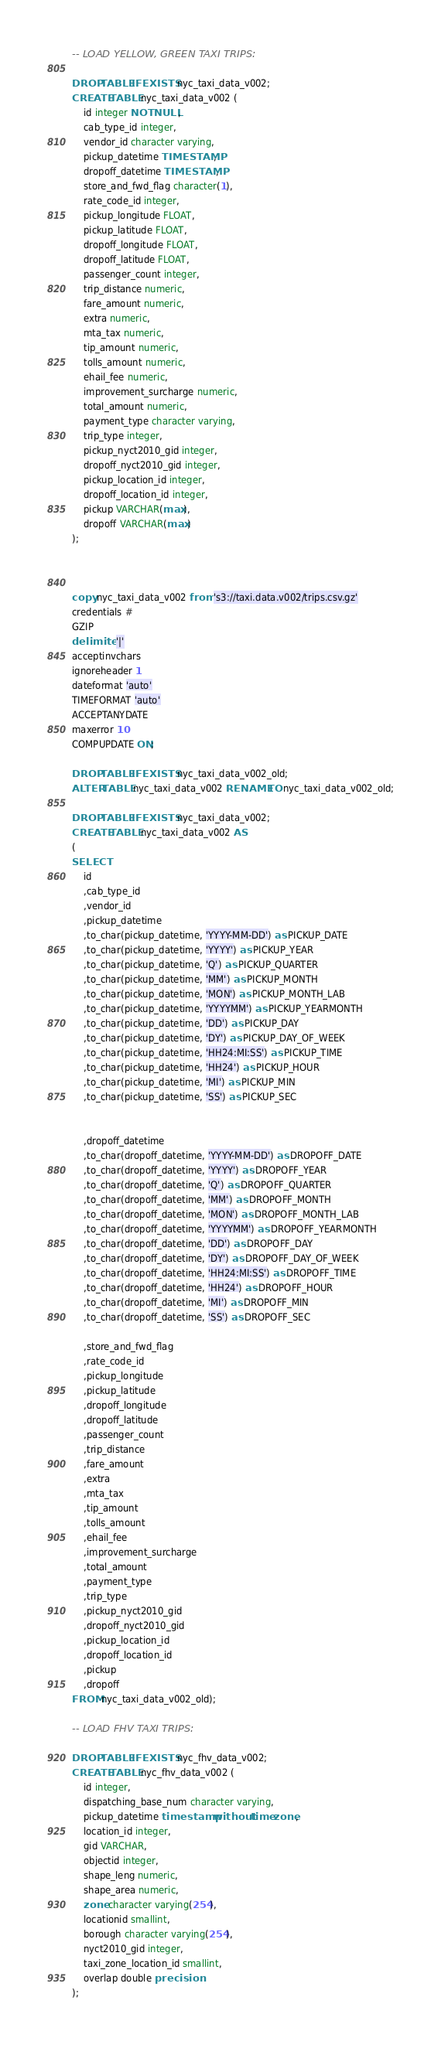<code> <loc_0><loc_0><loc_500><loc_500><_SQL_>-- LOAD YELLOW, GREEN TAXI TRIPS:

DROP TABLE IF EXISTS nyc_taxi_data_v002;
CREATE TABLE nyc_taxi_data_v002 (
    id integer NOT NULL,
    cab_type_id integer,
    vendor_id character varying,
    pickup_datetime TIMESTAMP,
    dropoff_datetime TIMESTAMP,
    store_and_fwd_flag character(1),
    rate_code_id integer,
    pickup_longitude FLOAT,
    pickup_latitude FLOAT,
    dropoff_longitude FLOAT,
    dropoff_latitude FLOAT,
    passenger_count integer,
    trip_distance numeric,
    fare_amount numeric,
    extra numeric,
    mta_tax numeric,
    tip_amount numeric,
    tolls_amount numeric,
    ehail_fee numeric,
    improvement_surcharge numeric,
    total_amount numeric,
    payment_type character varying,
    trip_type integer,
    pickup_nyct2010_gid integer,
    dropoff_nyct2010_gid integer,
    pickup_location_id integer,
    dropoff_location_id integer,
    pickup VARCHAR(max),
    dropoff VARCHAR(max)
);



copy nyc_taxi_data_v002 from 's3://taxi.data.v002/trips.csv.gz'
credentials #
GZIP
delimiter '|'
acceptinvchars
ignoreheader 1
dateformat 'auto'
TIMEFORMAT 'auto'
ACCEPTANYDATE
maxerror 10
COMPUPDATE ON;

DROP TABLE IF EXISTS nyc_taxi_data_v002_old;
ALTER TABLE nyc_taxi_data_v002 RENAME TO nyc_taxi_data_v002_old;

DROP TABLE IF EXISTS nyc_taxi_data_v002;
CREATE TABLE nyc_taxi_data_v002 AS 
(
SELECT 
    id 
    ,cab_type_id
    ,vendor_id
    ,pickup_datetime
    ,to_char(pickup_datetime, 'YYYY-MM-DD') as PICKUP_DATE
    ,to_char(pickup_datetime, 'YYYY') as PICKUP_YEAR
    ,to_char(pickup_datetime, 'Q') as PICKUP_QUARTER
    ,to_char(pickup_datetime, 'MM') as PICKUP_MONTH
    ,to_char(pickup_datetime, 'MON') as PICKUP_MONTH_LAB
    ,to_char(pickup_datetime, 'YYYYMM') as PICKUP_YEARMONTH
    ,to_char(pickup_datetime, 'DD') as PICKUP_DAY
    ,to_char(pickup_datetime, 'DY') as PICKUP_DAY_OF_WEEK
    ,to_char(pickup_datetime, 'HH24:MI:SS') as PICKUP_TIME
    ,to_char(pickup_datetime, 'HH24') as PICKUP_HOUR
    ,to_char(pickup_datetime, 'MI') as PICKUP_MIN
    ,to_char(pickup_datetime, 'SS') as PICKUP_SEC

    
    ,dropoff_datetime
    ,to_char(dropoff_datetime, 'YYYY-MM-DD') as DROPOFF_DATE
    ,to_char(dropoff_datetime, 'YYYY') as DROPOFF_YEAR
    ,to_char(dropoff_datetime, 'Q') as DROPOFF_QUARTER
    ,to_char(dropoff_datetime, 'MM') as DROPOFF_MONTH
    ,to_char(dropoff_datetime, 'MON') as DROPOFF_MONTH_LAB
    ,to_char(dropoff_datetime, 'YYYYMM') as DROPOFF_YEARMONTH
    ,to_char(dropoff_datetime, 'DD') as DROPOFF_DAY
    ,to_char(dropoff_datetime, 'DY') as DROPOFF_DAY_OF_WEEK
    ,to_char(dropoff_datetime, 'HH24:MI:SS') as DROPOFF_TIME
    ,to_char(dropoff_datetime, 'HH24') as DROPOFF_HOUR
    ,to_char(dropoff_datetime, 'MI') as DROPOFF_MIN
    ,to_char(dropoff_datetime, 'SS') as DROPOFF_SEC
    
    ,store_and_fwd_flag
    ,rate_code_id
    ,pickup_longitude
    ,pickup_latitude
    ,dropoff_longitude
    ,dropoff_latitude
    ,passenger_count
    ,trip_distance
    ,fare_amount
    ,extra
    ,mta_tax
    ,tip_amount
    ,tolls_amount
    ,ehail_fee
    ,improvement_surcharge
    ,total_amount
    ,payment_type
    ,trip_type
    ,pickup_nyct2010_gid
    ,dropoff_nyct2010_gid
    ,pickup_location_id
    ,dropoff_location_id
    ,pickup
    ,dropoff
FROM nyc_taxi_data_v002_old);

-- LOAD FHV TAXI TRIPS:

DROP TABLE IF EXISTS nyc_fhv_data_v002;
CREATE TABLE nyc_fhv_data_v002 (
    id integer,
    dispatching_base_num character varying,
    pickup_datetime timestamp without time zone,
    location_id integer,
    gid VARCHAR,
    objectid integer,
    shape_leng numeric,
    shape_area numeric,
    zone character varying(254),
    locationid smallint,
    borough character varying(254),
    nyct2010_gid integer,
    taxi_zone_location_id smallint,
    overlap double precision
);


</code> 